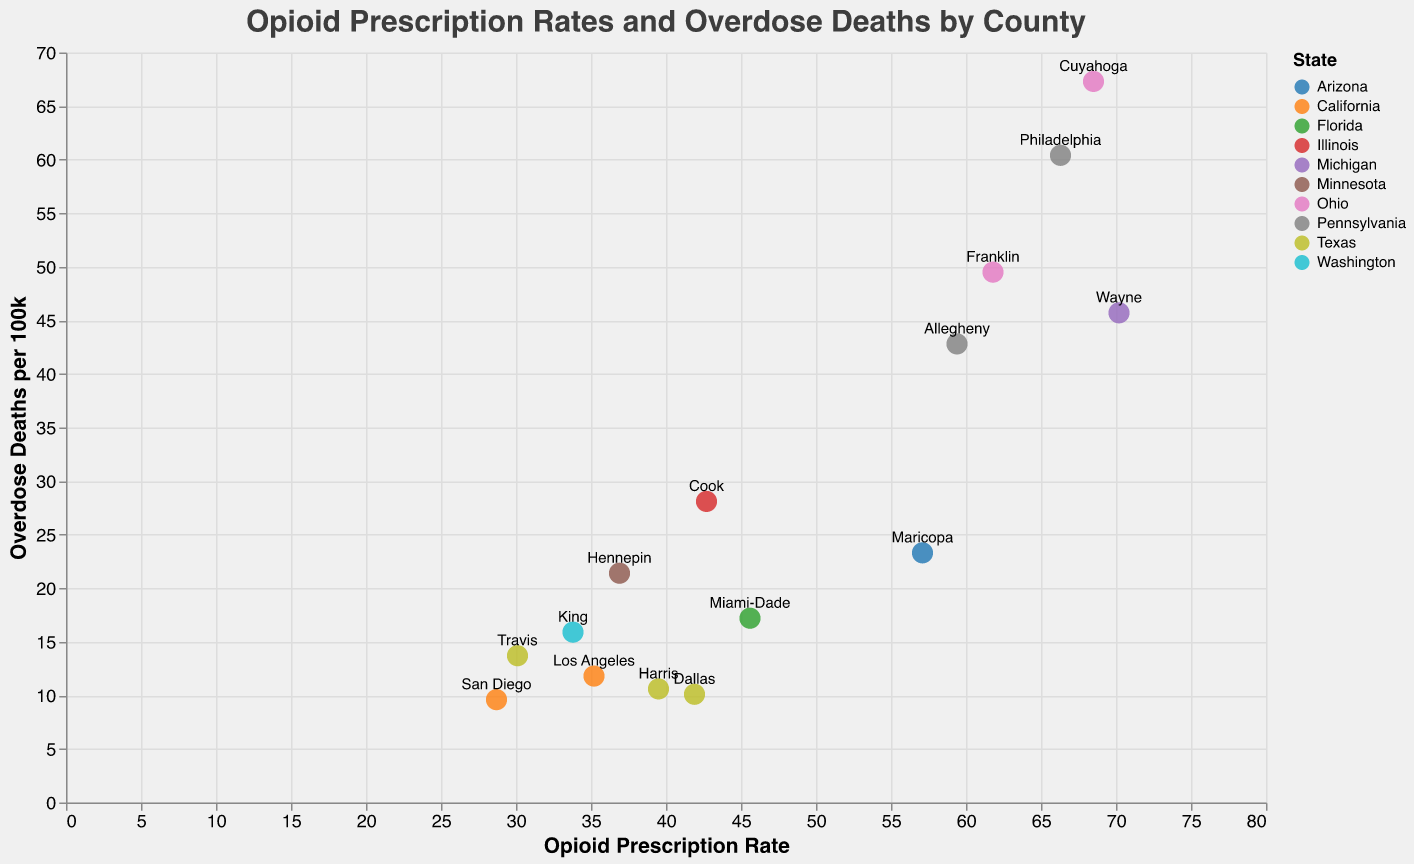What is the title of the figure? The title of the figure is displayed at the top of the plot and is "Opioid Prescription Rates and Overdose Deaths by County".
Answer: Opioid Prescription Rates and Overdose Deaths by County Which county has the highest opioid prescription rate? By examining the "Opioid Prescription Rate" axis, Wayne County in Michigan has the highest rate of 70.2.
Answer: Wayne How do the opioid prescription rates of Texas's counties compare? For Texas, the counties listed are Harris, Dallas, and Travis. Their rates are 39.5, 41.9, and 30.1 respectively. Comparing these, Dallas has the highest, followed by Harris, then Travis.
Answer: Dallas > Harris > Travis Which county has the most overdose deaths per 100k? By examining the "Overdose Deaths per 100k" axis, Cuyahoga County in Ohio shows the highest value of 67.3 deaths per 100k.
Answer: Cuyahoga What is the average opioid prescription rate across all counties? Summing all the opioid prescription rates and dividing by the number of counties (15): (35.2 + 42.7 + 39.5 + 57.1 + 66.3 + 33.8 + 45.6 + 41.9 + 28.7 + 70.2 + 61.8 + 59.4 + 68.5 + 36.9 + 30.1)/15 = 47.32
Answer: 47.3 How does Cook County's overdose death rate compare to Maricopa County's? Cook County has an overdose death rate of 28.1 per 100k, while Maricopa County has a rate of 23.3 per 100k. Cook County has a higher rate.
Answer: Cook > Maricopa Which state appears most frequently in the figure? To determine this, count the occurrences of each state in the figure. Texas appears three times (Harris, Dallas, Travis), more than any other state.
Answer: Texas How many counties have an overdose death rate higher than 40 per 100k? Checking each county's overdose death rate, the counties with rates above 40 per 100k are Philadelphia, Wayne, Franklin, Allegheny, and Cuyahoga. There are 5 counties.
Answer: 5 Which county in Pennsylvania has a higher opioid prescription rate, Philadelphia or Allegheny? Philadelphia's rate is 66.3, while Allegheny's rate is 59.4. Philadelphia has a higher rate.
Answer: Philadelphia > Allegheny What correlation, if any, can be inferred between opioid prescription rate and overdose death rates from the figure? By observing the plot, there seems to be a general trend where higher opioid prescription rates are associated with higher overdose death rates, but the correlation is not perfectly linear as some counties with lower prescription rates have high overdose rates and vice versa.
Answer: Positive correlation 